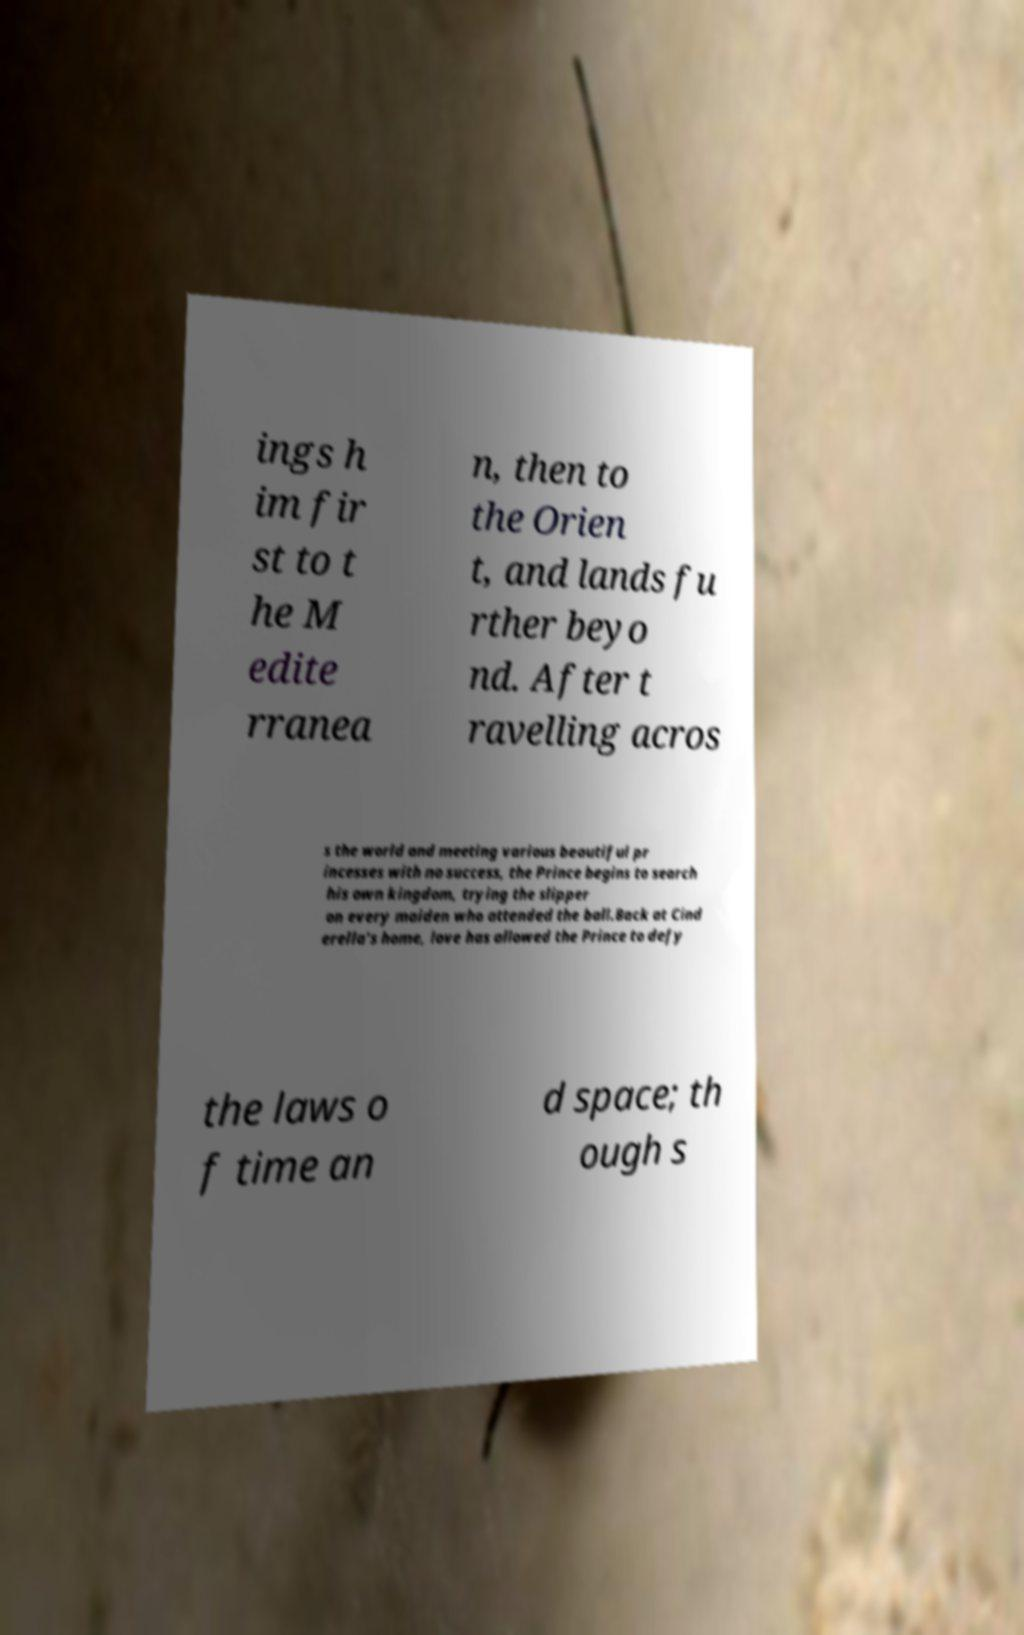What messages or text are displayed in this image? I need them in a readable, typed format. ings h im fir st to t he M edite rranea n, then to the Orien t, and lands fu rther beyo nd. After t ravelling acros s the world and meeting various beautiful pr incesses with no success, the Prince begins to search his own kingdom, trying the slipper on every maiden who attended the ball.Back at Cind erella's home, love has allowed the Prince to defy the laws o f time an d space; th ough s 